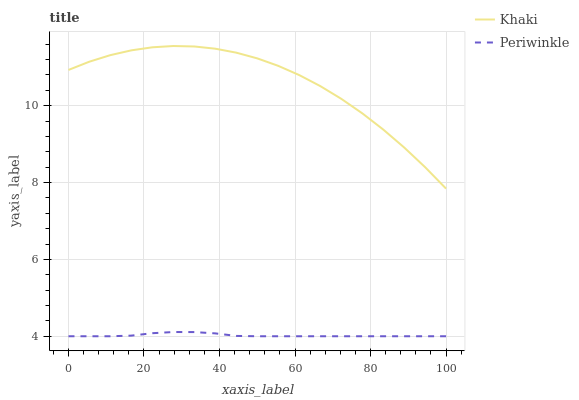Does Periwinkle have the minimum area under the curve?
Answer yes or no. Yes. Does Khaki have the maximum area under the curve?
Answer yes or no. Yes. Does Periwinkle have the maximum area under the curve?
Answer yes or no. No. Is Periwinkle the smoothest?
Answer yes or no. Yes. Is Khaki the roughest?
Answer yes or no. Yes. Is Periwinkle the roughest?
Answer yes or no. No. Does Periwinkle have the lowest value?
Answer yes or no. Yes. Does Khaki have the highest value?
Answer yes or no. Yes. Does Periwinkle have the highest value?
Answer yes or no. No. Is Periwinkle less than Khaki?
Answer yes or no. Yes. Is Khaki greater than Periwinkle?
Answer yes or no. Yes. Does Periwinkle intersect Khaki?
Answer yes or no. No. 